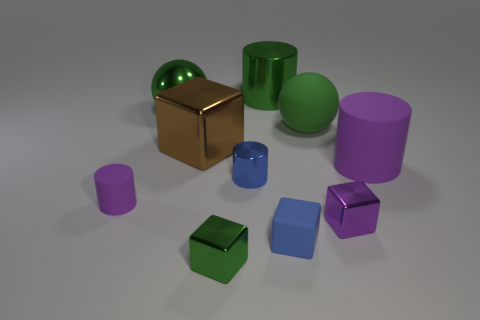Subtract 1 blocks. How many blocks are left? 3 Subtract all cubes. How many objects are left? 6 Add 7 large blue metallic objects. How many large blue metallic objects exist? 7 Subtract 0 blue balls. How many objects are left? 10 Subtract all purple blocks. Subtract all yellow rubber cubes. How many objects are left? 9 Add 2 tiny purple shiny blocks. How many tiny purple shiny blocks are left? 3 